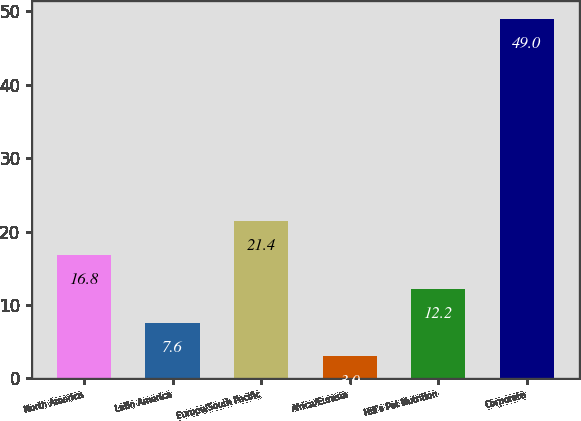<chart> <loc_0><loc_0><loc_500><loc_500><bar_chart><fcel>North America<fcel>Latin America<fcel>Europe/South Pacific<fcel>Africa/Eurasia<fcel>Hill's Pet Nutrition<fcel>Corporate<nl><fcel>16.8<fcel>7.6<fcel>21.4<fcel>3<fcel>12.2<fcel>49<nl></chart> 